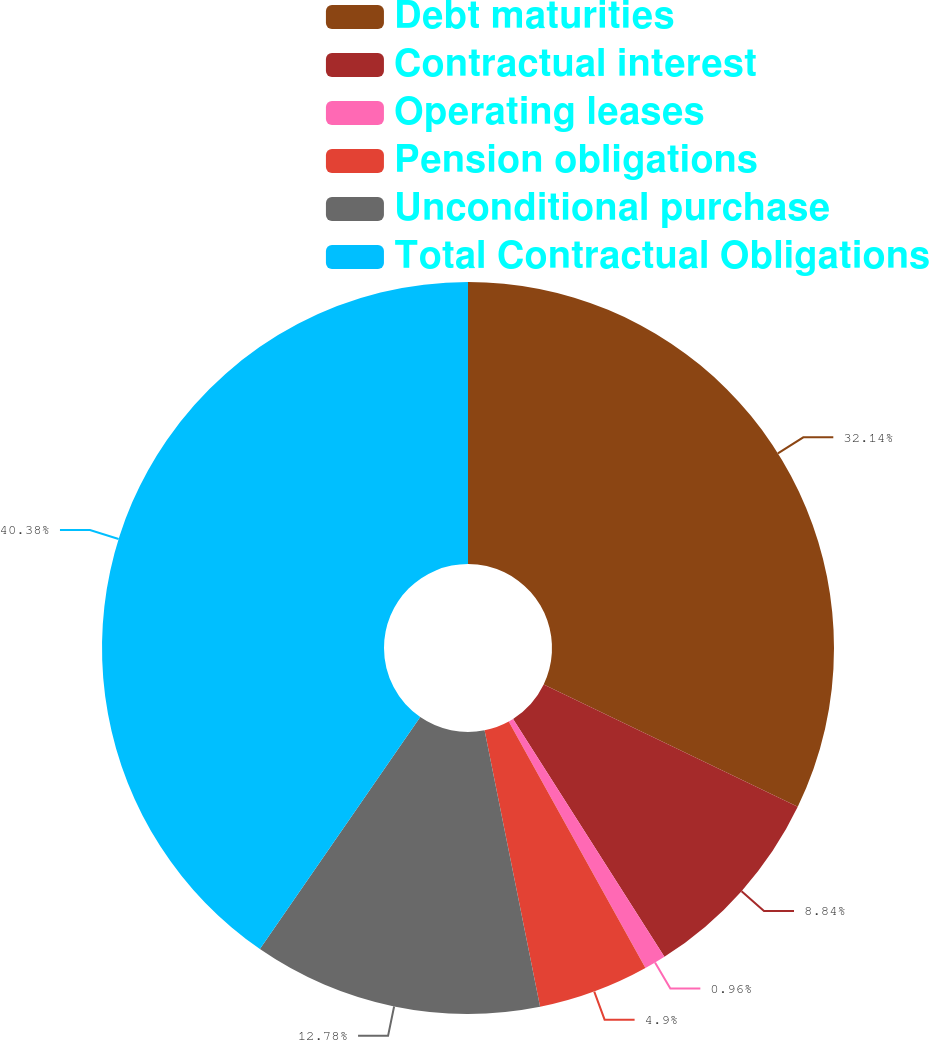Convert chart to OTSL. <chart><loc_0><loc_0><loc_500><loc_500><pie_chart><fcel>Debt maturities<fcel>Contractual interest<fcel>Operating leases<fcel>Pension obligations<fcel>Unconditional purchase<fcel>Total Contractual Obligations<nl><fcel>32.14%<fcel>8.84%<fcel>0.96%<fcel>4.9%<fcel>12.78%<fcel>40.37%<nl></chart> 